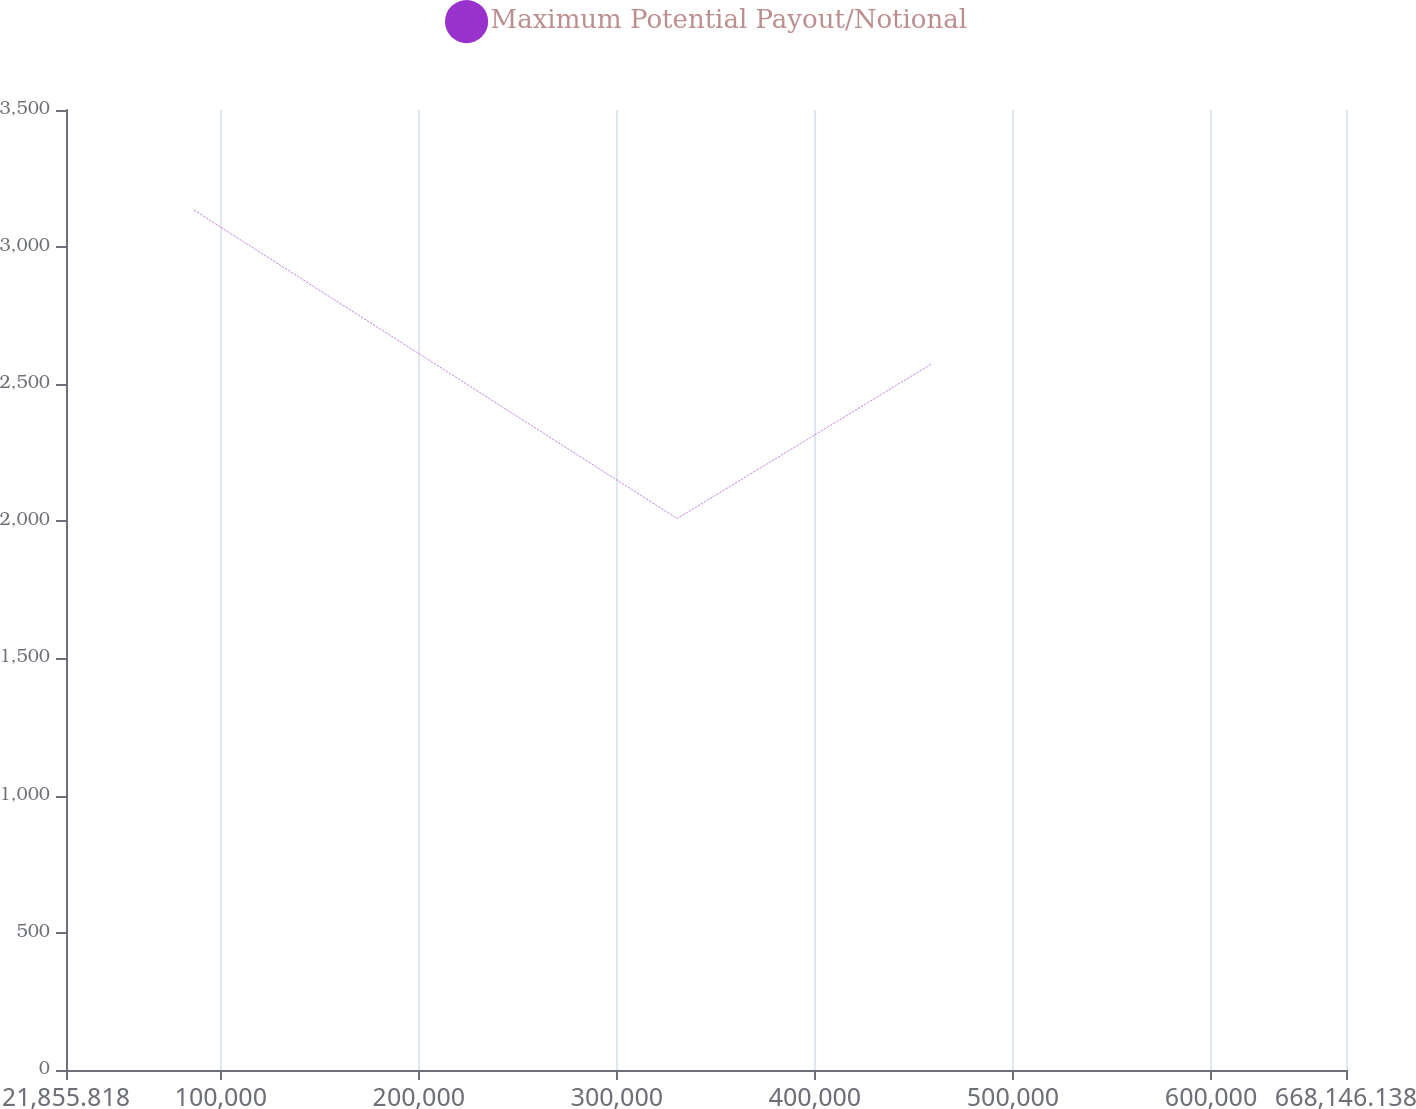Convert chart to OTSL. <chart><loc_0><loc_0><loc_500><loc_500><line_chart><ecel><fcel>Maximum Potential Payout/Notional<nl><fcel>86484.9<fcel>3134.95<nl><fcel>330441<fcel>2010.57<nl><fcel>458556<fcel>2572.76<nl><fcel>732775<fcel>7632.47<nl></chart> 